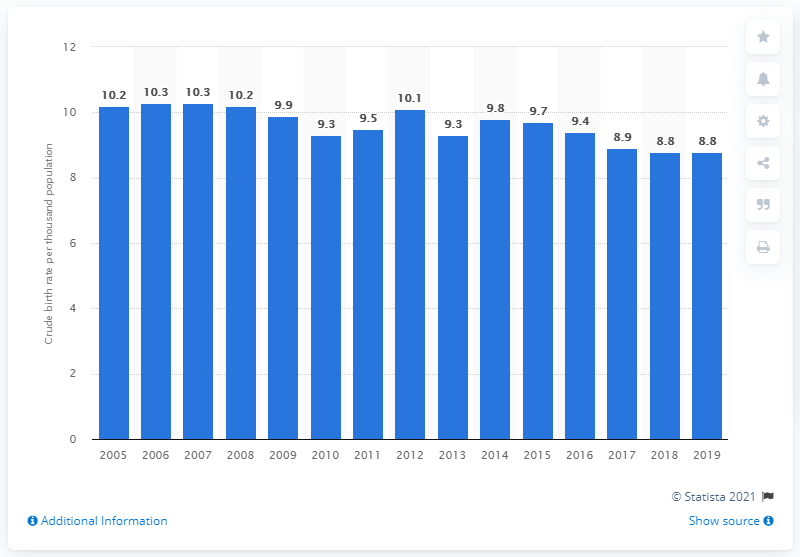Identify some key points in this picture. The crude birth rate in Singapore in 2019 was 8.8. 